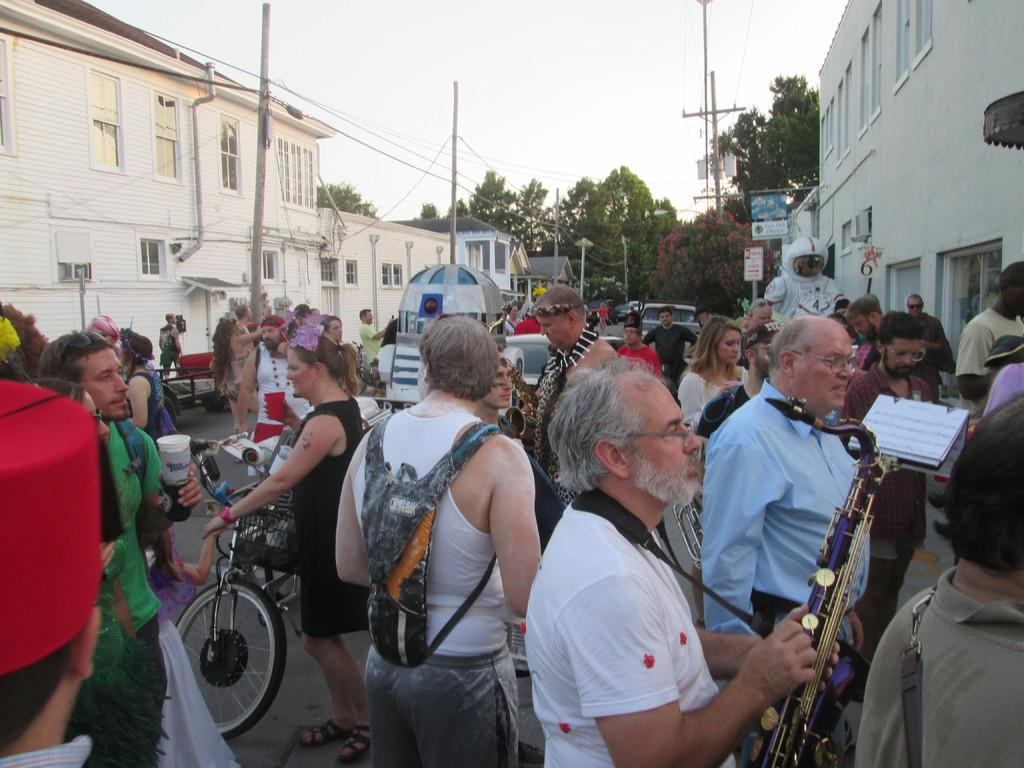What are the people in the image doing? The people in the image are standing on a road. What else can be seen on the road in the image? There are vehicles on the road. What is visible on either side of the road in the image? There are buildings and poles on either side of the road. What can be seen in the background of the image? There are trees and the sky visible in the background of the image. Can you see a tray being used by the people in the image? There is no tray present in the image. Is there a receipt visible in the image? There is no receipt visible in the image. 